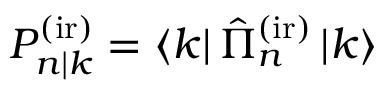<formula> <loc_0><loc_0><loc_500><loc_500>P _ { n | k } ^ { ( i r ) } = \left \langle k \right | \hat { \Pi } _ { n } ^ { ( i r ) } \left | k \right \rangle</formula> 